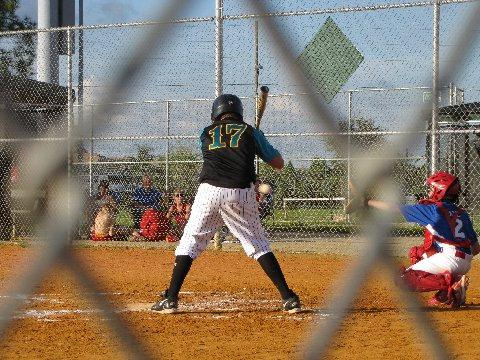Question: what are they playing?
Choices:
A. Basketball.
B. Baseball.
C. Hopscotch.
D. Football.
Answer with the letter. Answer: B Question: who will catch the ball?
Choices:
A. Catcher.
B. Pitcher.
C. Outfielder.
D. Umpire.
Answer with the letter. Answer: A Question: what color are his pants?
Choices:
A. White.
B. Black.
C. Tan.
D. Brown.
Answer with the letter. Answer: A 